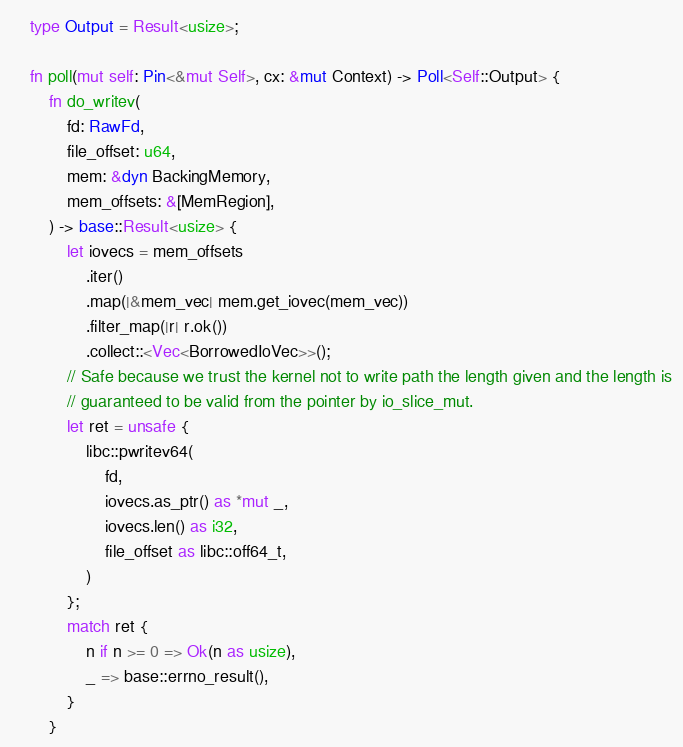Convert code to text. <code><loc_0><loc_0><loc_500><loc_500><_Rust_>    type Output = Result<usize>;

    fn poll(mut self: Pin<&mut Self>, cx: &mut Context) -> Poll<Self::Output> {
        fn do_writev(
            fd: RawFd,
            file_offset: u64,
            mem: &dyn BackingMemory,
            mem_offsets: &[MemRegion],
        ) -> base::Result<usize> {
            let iovecs = mem_offsets
                .iter()
                .map(|&mem_vec| mem.get_iovec(mem_vec))
                .filter_map(|r| r.ok())
                .collect::<Vec<BorrowedIoVec>>();
            // Safe because we trust the kernel not to write path the length given and the length is
            // guaranteed to be valid from the pointer by io_slice_mut.
            let ret = unsafe {
                libc::pwritev64(
                    fd,
                    iovecs.as_ptr() as *mut _,
                    iovecs.len() as i32,
                    file_offset as libc::off64_t,
                )
            };
            match ret {
                n if n >= 0 => Ok(n as usize),
                _ => base::errno_result(),
            }
        }
</code> 